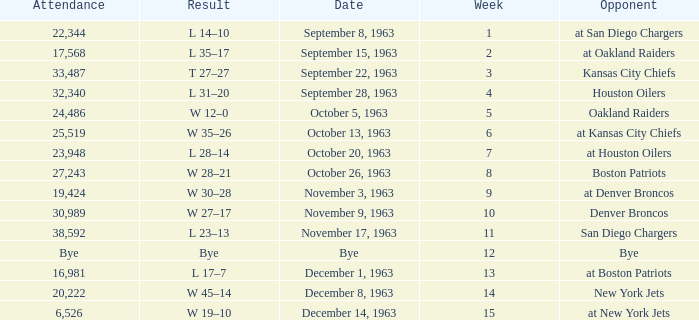Which Opponent has a Date of november 17, 1963? San Diego Chargers. Give me the full table as a dictionary. {'header': ['Attendance', 'Result', 'Date', 'Week', 'Opponent'], 'rows': [['22,344', 'L 14–10', 'September 8, 1963', '1', 'at San Diego Chargers'], ['17,568', 'L 35–17', 'September 15, 1963', '2', 'at Oakland Raiders'], ['33,487', 'T 27–27', 'September 22, 1963', '3', 'Kansas City Chiefs'], ['32,340', 'L 31–20', 'September 28, 1963', '4', 'Houston Oilers'], ['24,486', 'W 12–0', 'October 5, 1963', '5', 'Oakland Raiders'], ['25,519', 'W 35–26', 'October 13, 1963', '6', 'at Kansas City Chiefs'], ['23,948', 'L 28–14', 'October 20, 1963', '7', 'at Houston Oilers'], ['27,243', 'W 28–21', 'October 26, 1963', '8', 'Boston Patriots'], ['19,424', 'W 30–28', 'November 3, 1963', '9', 'at Denver Broncos'], ['30,989', 'W 27–17', 'November 9, 1963', '10', 'Denver Broncos'], ['38,592', 'L 23–13', 'November 17, 1963', '11', 'San Diego Chargers'], ['Bye', 'Bye', 'Bye', '12', 'Bye'], ['16,981', 'L 17–7', 'December 1, 1963', '13', 'at Boston Patriots'], ['20,222', 'W 45–14', 'December 8, 1963', '14', 'New York Jets'], ['6,526', 'W 19–10', 'December 14, 1963', '15', 'at New York Jets']]} 